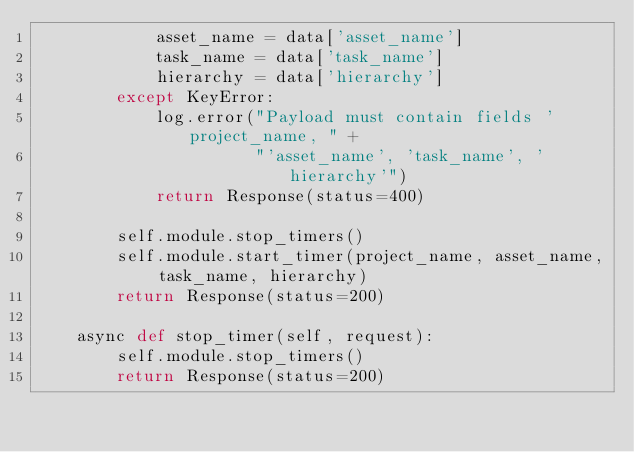Convert code to text. <code><loc_0><loc_0><loc_500><loc_500><_Python_>            asset_name = data['asset_name']
            task_name = data['task_name']
            hierarchy = data['hierarchy']
        except KeyError:
            log.error("Payload must contain fields 'project_name, " +
                      "'asset_name', 'task_name', 'hierarchy'")
            return Response(status=400)

        self.module.stop_timers()
        self.module.start_timer(project_name, asset_name, task_name, hierarchy)
        return Response(status=200)

    async def stop_timer(self, request):
        self.module.stop_timers()
        return Response(status=200)
</code> 